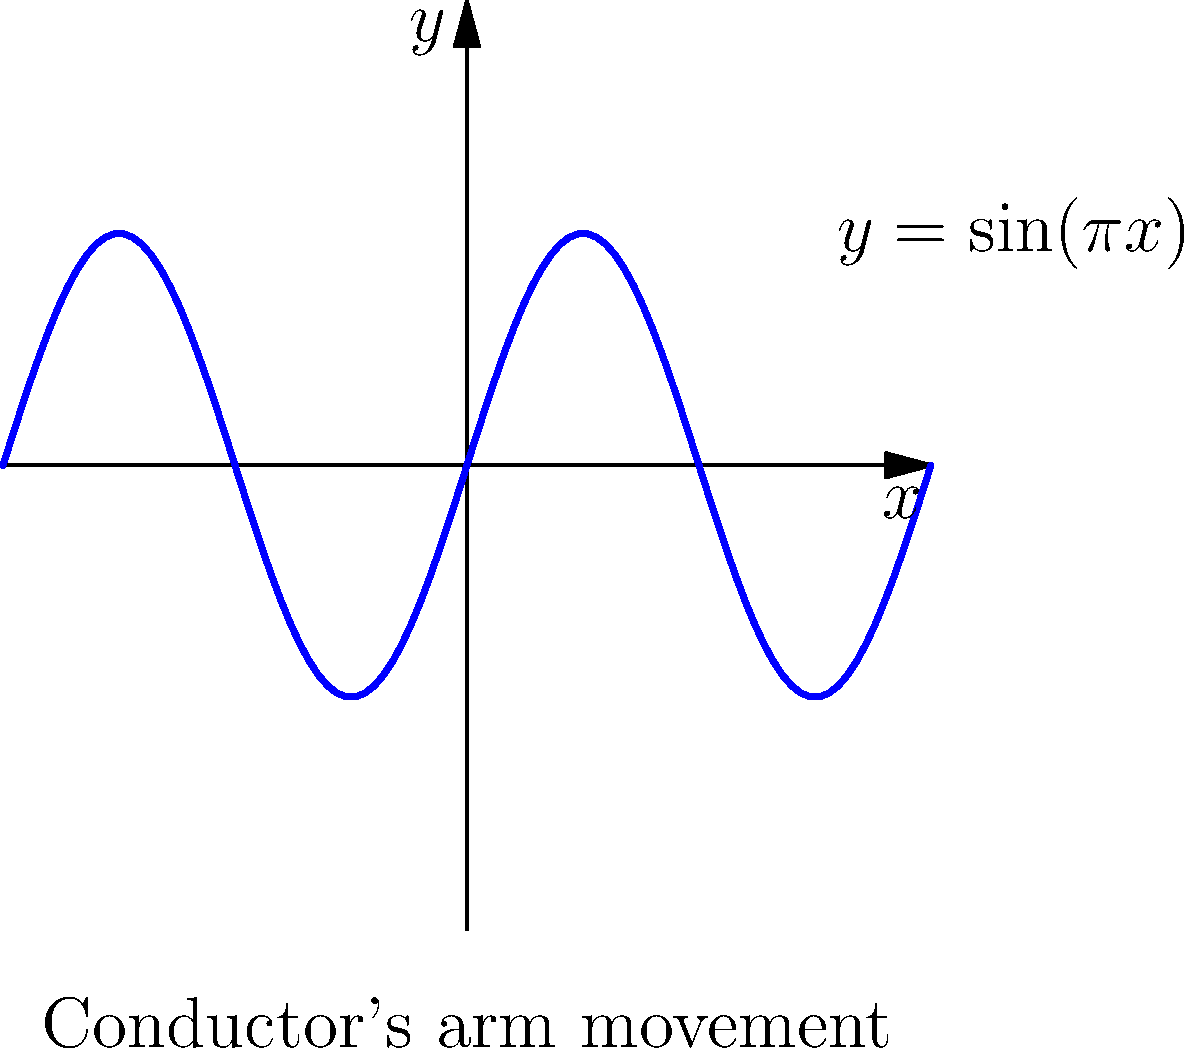Consider a conductor's arm movement modeled by the function $y = \sin(\pi x)$, where $y$ represents the vertical position of the conductor's hand and $x$ represents time normalized to a single beat. What is the maximum acceleration experienced by the conductor's hand during this movement? To find the maximum acceleration, we need to follow these steps:

1) First, we need to find the position function, which is given:
   $y(x) = \sin(\pi x)$

2) To get velocity, we differentiate the position function:
   $v(x) = y'(x) = \pi \cos(\pi x)$

3) To get acceleration, we differentiate the velocity function:
   $a(x) = v'(x) = -\pi^2 \sin(\pi x)$

4) The maximum acceleration will occur when $|\sin(\pi x)|$ is at its maximum, which is 1.

5) Therefore, the maximum acceleration (in absolute value) is:
   $|a_{max}| = \pi^2$

6) Since $\pi^2 \approx 9.87$, the maximum acceleration is approximately 9.87 units in either the positive or negative direction.

Note: The units would depend on how we define our time and position scales. If time is in seconds and position in meters, then the acceleration would be in m/s^2.
Answer: $\pi^2$ (or approximately 9.87) units 